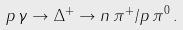<formula> <loc_0><loc_0><loc_500><loc_500>p \, \gamma \rightarrow \Delta ^ { + } \rightarrow n \, \pi ^ { + } / p \, \pi ^ { 0 } \, .</formula> 